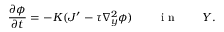Convert formula to latex. <formula><loc_0><loc_0><loc_500><loc_500>\frac { \partial \phi } { \partial t } = - K ( J ^ { \prime } - \tau \nabla _ { y } ^ { 2 } \phi ) \quad i n \quad Y .</formula> 